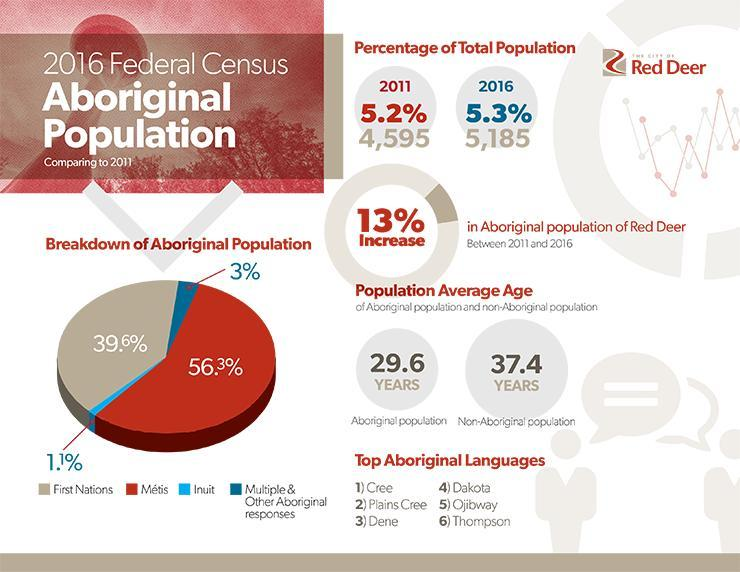What percentage of the total population in Canada are First Nations in 2016?
Answer the question with a short phrase. 5,185 What is the average age of the non-aboriginal population according to the 2016 Federal Census? 37.4 YEARS What percentage of the aboriginal population in Canada are Inuit according to the 2016 Federal Census? 1.1% 